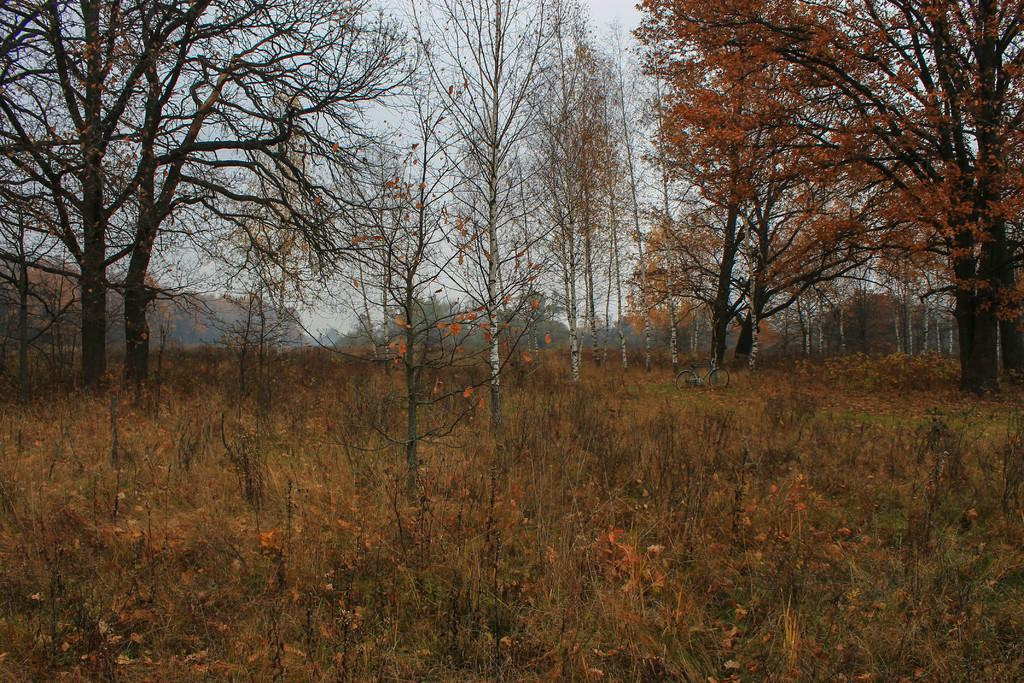What type of vegetation is present on the ground in the image? There are plants on the ground in the image. What other type of vegetation can be seen in the image? There are trees in the image. What is the color of the leaves on the trees in the image? The trees have orange-colored leaves on the right side. What can be seen in the background of the image? There is a sky visible in the background of the image. What is the cause of the orange-colored leaves on the trees in the image? The cause of the orange-colored leaves on the trees in the image is not mentioned in the provided facts. What type of pleasure can be derived from the plants and trees in the image? The provided facts do not mention any pleasure derived from the plants and trees in the image. 